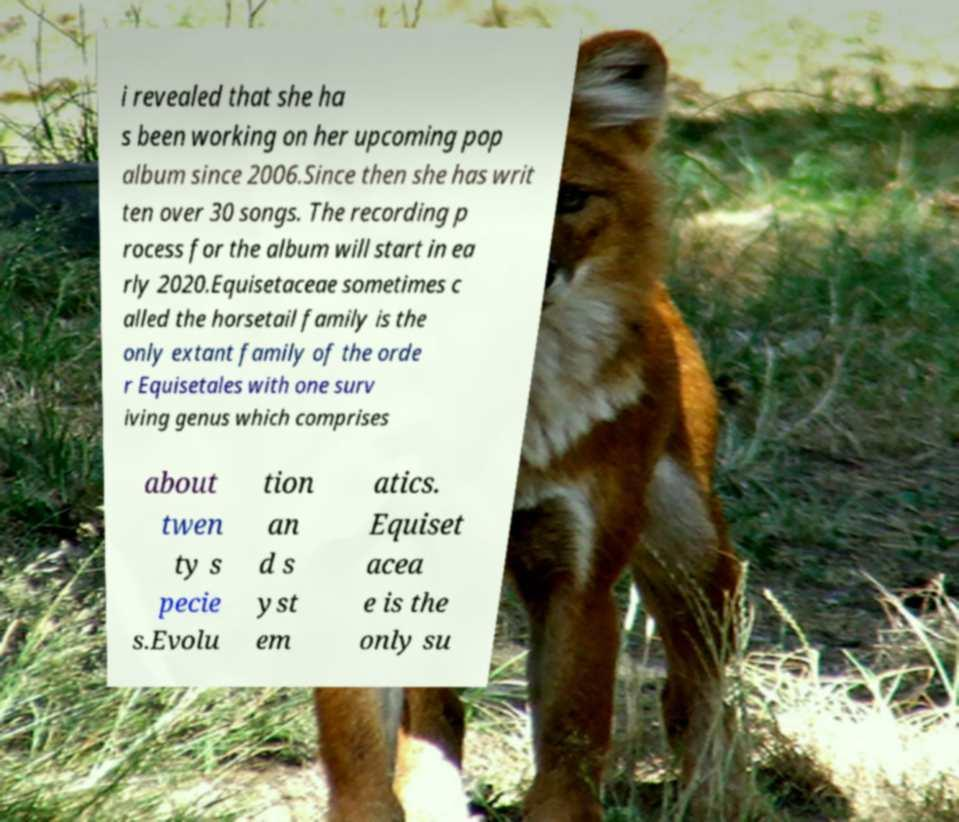Could you extract and type out the text from this image? i revealed that she ha s been working on her upcoming pop album since 2006.Since then she has writ ten over 30 songs. The recording p rocess for the album will start in ea rly 2020.Equisetaceae sometimes c alled the horsetail family is the only extant family of the orde r Equisetales with one surv iving genus which comprises about twen ty s pecie s.Evolu tion an d s yst em atics. Equiset acea e is the only su 